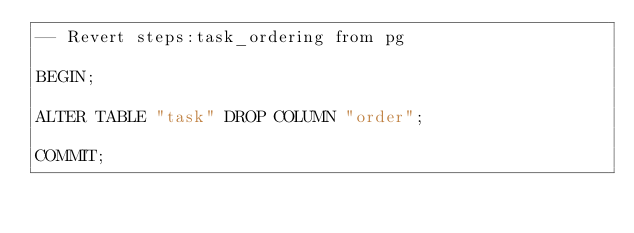Convert code to text. <code><loc_0><loc_0><loc_500><loc_500><_SQL_>-- Revert steps:task_ordering from pg

BEGIN;

ALTER TABLE "task" DROP COLUMN "order";

COMMIT;
</code> 